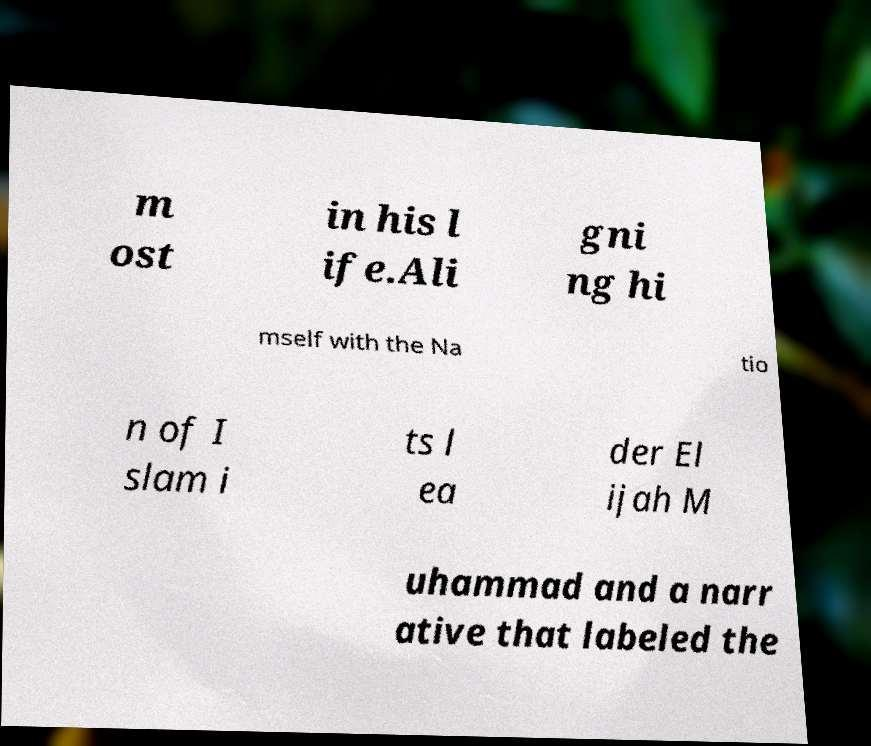Can you accurately transcribe the text from the provided image for me? m ost in his l ife.Ali gni ng hi mself with the Na tio n of I slam i ts l ea der El ijah M uhammad and a narr ative that labeled the 